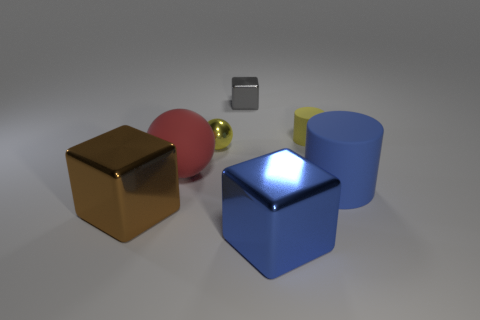Add 1 shiny cubes. How many objects exist? 8 Subtract all blocks. How many objects are left? 4 Add 4 big blue rubber things. How many big blue rubber things exist? 5 Subtract 1 red spheres. How many objects are left? 6 Subtract all brown blocks. Subtract all small spheres. How many objects are left? 5 Add 2 shiny blocks. How many shiny blocks are left? 5 